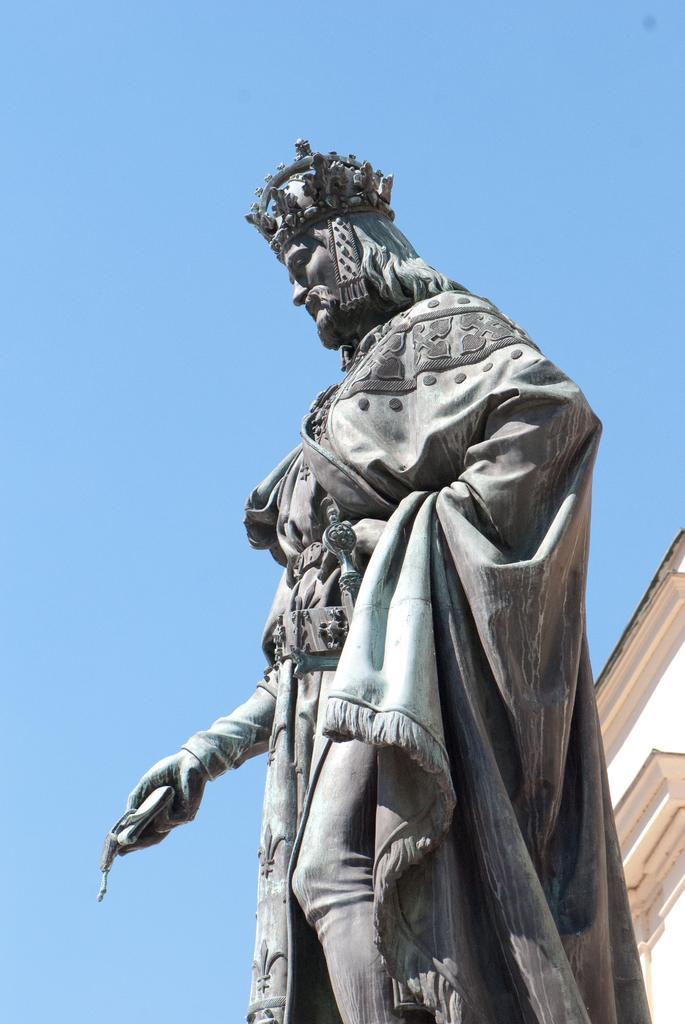Can you describe this image briefly? In the middle of the picture, we see the statue of the man. In the right bottom, we see a building in white and brown color. In the background, we see the sky, which is blue in color. 